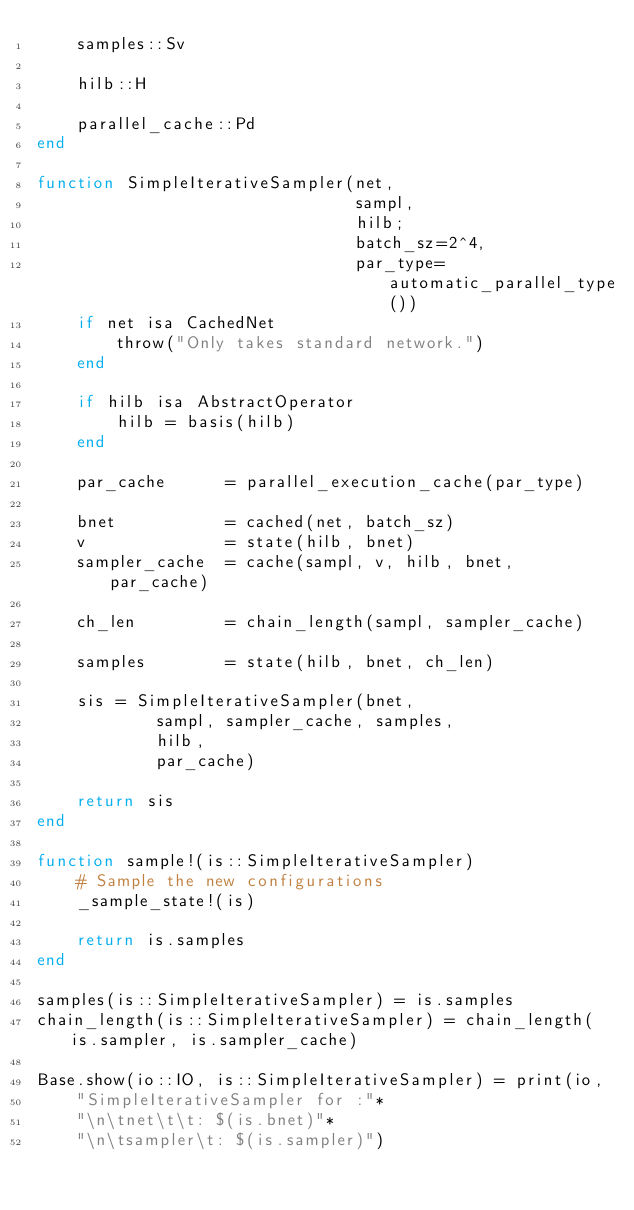<code> <loc_0><loc_0><loc_500><loc_500><_Julia_>    samples::Sv

    hilb::H

    parallel_cache::Pd
end

function SimpleIterativeSampler(net,
                                sampl,
                                hilb;
                                batch_sz=2^4,
                                par_type=automatic_parallel_type())
    if net isa CachedNet
        throw("Only takes standard network.")
    end

    if hilb isa AbstractOperator
        hilb = basis(hilb)
    end

    par_cache      = parallel_execution_cache(par_type)

    bnet           = cached(net, batch_sz)
    v              = state(hilb, bnet)
    sampler_cache  = cache(sampl, v, hilb, bnet, par_cache)

    ch_len         = chain_length(sampl, sampler_cache)

    samples        = state(hilb, bnet, ch_len)

    sis = SimpleIterativeSampler(bnet,
            sampl, sampler_cache, samples,
            hilb,
            par_cache)

    return sis
end

function sample!(is::SimpleIterativeSampler)
    # Sample the new configurations
    _sample_state!(is)

    return is.samples
end

samples(is::SimpleIterativeSampler) = is.samples
chain_length(is::SimpleIterativeSampler) = chain_length(is.sampler, is.sampler_cache)

Base.show(io::IO, is::SimpleIterativeSampler) = print(io,
    "SimpleIterativeSampler for :"*
    "\n\tnet\t\t: $(is.bnet)"*
    "\n\tsampler\t: $(is.sampler)")
</code> 